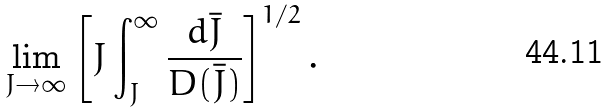Convert formula to latex. <formula><loc_0><loc_0><loc_500><loc_500>\lim _ { J \to \infty } \left [ J \int _ { J } ^ { \infty } \frac { d \bar { J } } { D ( \bar { J } ) } \right ] ^ { 1 / 2 } .</formula> 